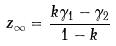<formula> <loc_0><loc_0><loc_500><loc_500>z _ { \infty } = \frac { k \gamma _ { 1 } - \gamma _ { 2 } } { 1 - k }</formula> 